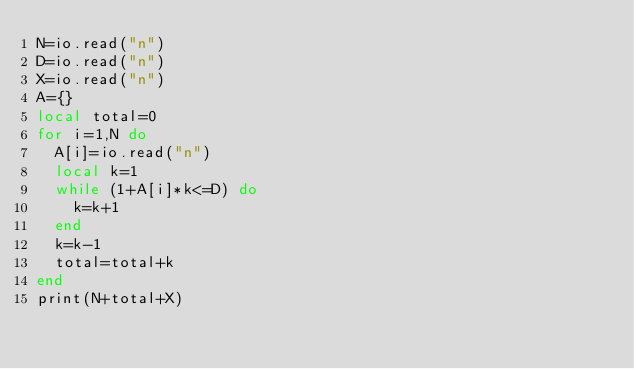Convert code to text. <code><loc_0><loc_0><loc_500><loc_500><_Lua_>N=io.read("n")
D=io.read("n")
X=io.read("n")
A={}
local total=0
for i=1,N do
  A[i]=io.read("n")
  local k=1
  while (1+A[i]*k<=D) do
    k=k+1
  end
  k=k-1
  total=total+k
end
print(N+total+X)
</code> 